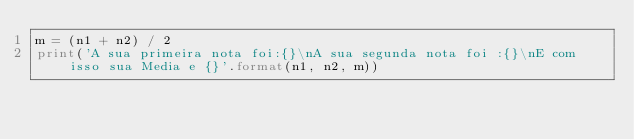<code> <loc_0><loc_0><loc_500><loc_500><_Python_>m = (n1 + n2) / 2
print('A sua primeira nota foi:{}\nA sua segunda nota foi :{}\nE com isso sua Media e {}'.format(n1, n2, m))</code> 